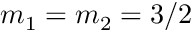<formula> <loc_0><loc_0><loc_500><loc_500>m _ { 1 } = m _ { 2 } = 3 / 2</formula> 